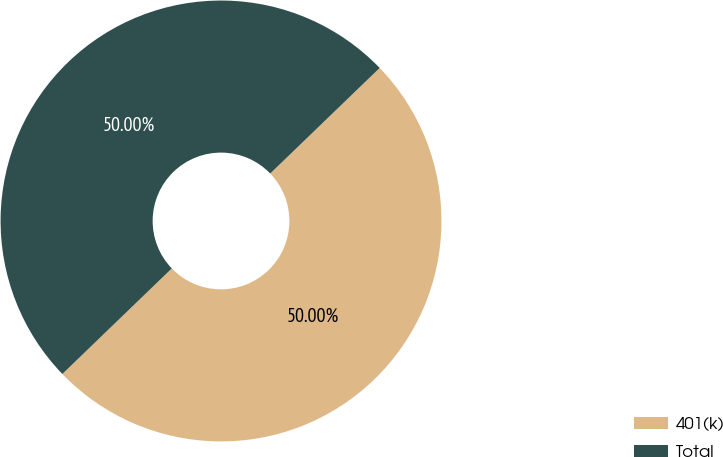Convert chart to OTSL. <chart><loc_0><loc_0><loc_500><loc_500><pie_chart><fcel>401(k)<fcel>Total<nl><fcel>50.0%<fcel>50.0%<nl></chart> 